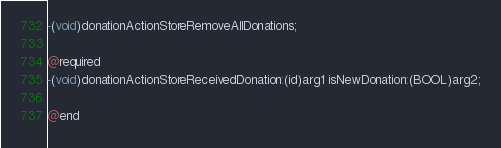<code> <loc_0><loc_0><loc_500><loc_500><_C_>-(void)donationActionStoreRemoveAllDonations;

@required
-(void)donationActionStoreReceivedDonation:(id)arg1 isNewDonation:(BOOL)arg2;

@end

</code> 